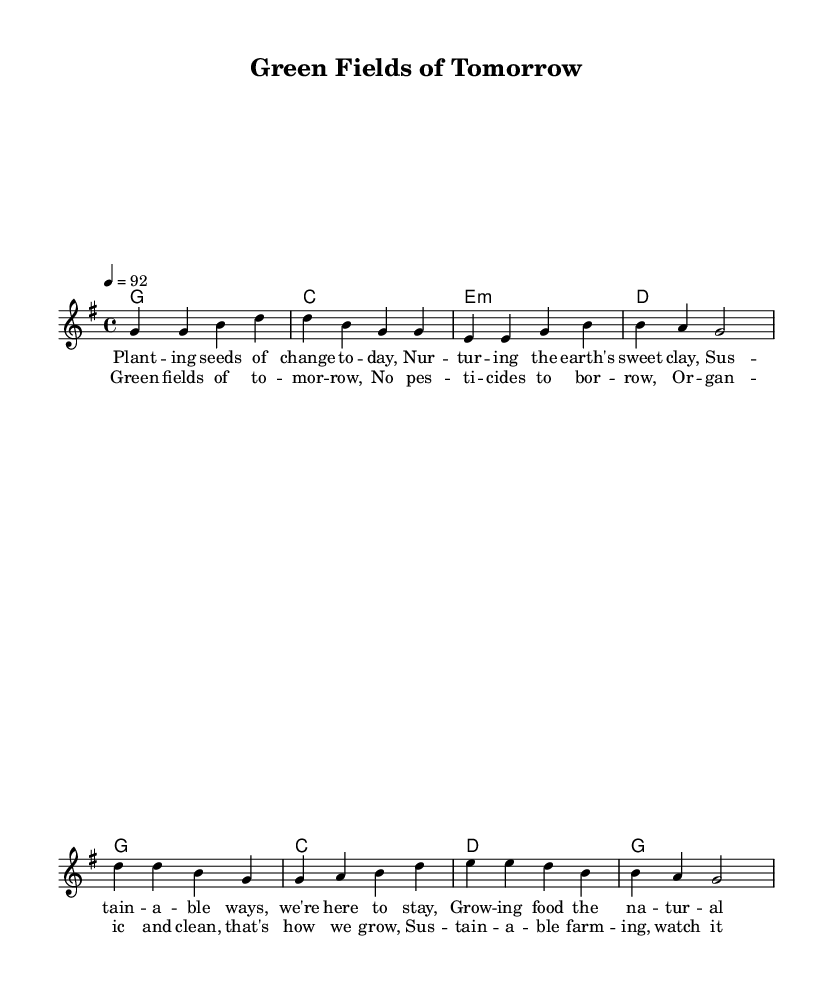What is the key signature of this music? The key signature shown is G major, which has one sharp (F#). This can be determined by the presence of the appropriate sharp symbol in the beginning of the staff.
Answer: G major What is the time signature of this music? The time signature displayed at the beginning of the music is 4/4, indicated by the "4/4" notation following the key signature. This means there are 4 beats in each measure and the quarter note gets one beat.
Answer: 4/4 What is the tempo marking of this music? The tempo marking indicates a speed of 92 beats per minute, noted at the start with "4 = 92." This specifies how quickly the music should be played.
Answer: 92 How many measures are in the verse section? The verse section consists of 4 measures, which can be counted from the melody section where each set of notes separated by bars represents a measure.
Answer: 4 What is the first line of the verse? The first line of the verse is "Planting seeds of change today," as indicated in the lyrics section aligned with the melody notes.
Answer: Planting seeds of change today How many chords are used in the verse section? There are 4 chords used in the verse section, specifically noted in the harmonies section, including G major, C major, E minor, and D major. These chords are structured over the 4 measures of the verse.
Answer: 4 What is the theme of the chorus? The theme of the chorus focuses on sustainable farming practices, highlighted by the lines discussing organic methods and avoiding pesticides. This theme aligns with the overall content of the sheet music.
Answer: Sustainable farming 